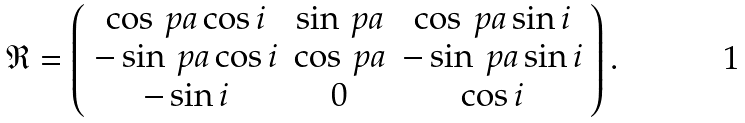Convert formula to latex. <formula><loc_0><loc_0><loc_500><loc_500>\mathfrak { R } = \left ( \begin{array} { c c c } \cos \ p a \cos i & \sin \ p a & \cos \ p a \sin i \\ - \sin \ p a \cos i & \cos \ p a & - \sin \ p a \sin i \\ - \sin i & 0 & \cos i \end{array} \right ) .</formula> 